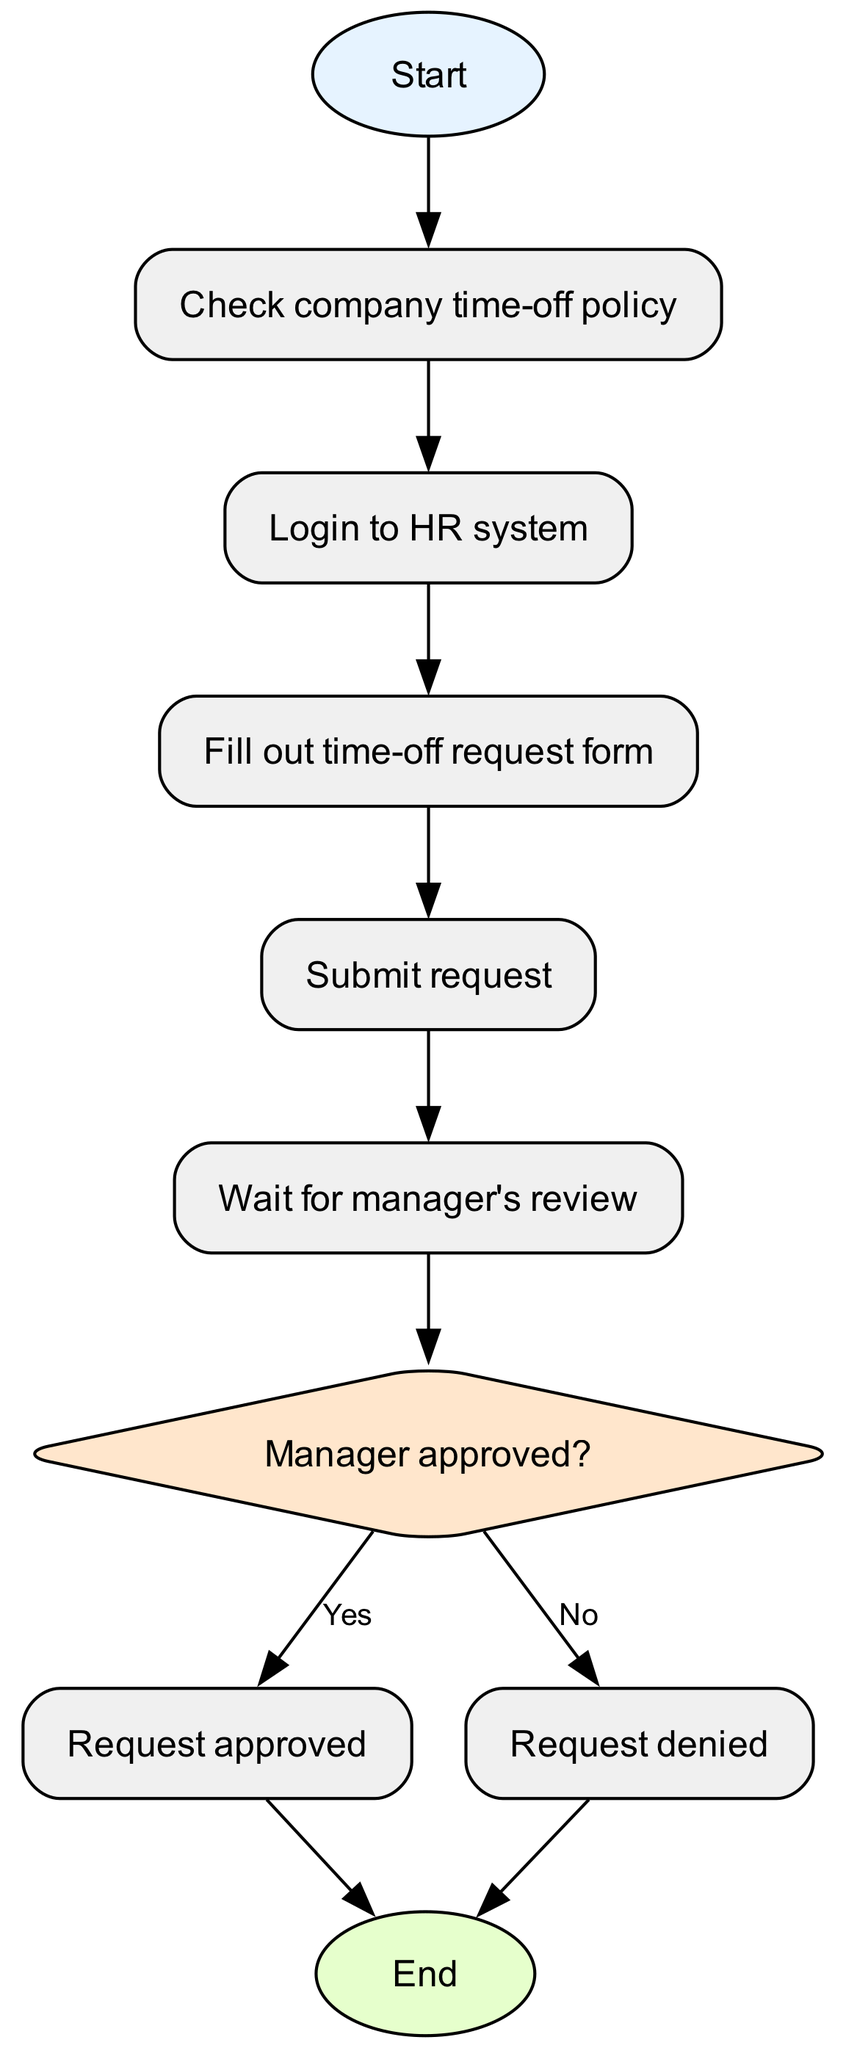What is the starting point of the process? The diagram begins with the "Start" node, indicating the entry point of the time-off request process.
Answer: Start What is the last step in the process? The process ends with the "End" node, signifying the completion of the time-off request flow.
Answer: End How many decision points are in the diagram? There is one decision node, asking if the manager approved the time-off request, which is a crucial point in the process.
Answer: 1 What comes after filling out the time-off request form? After the "Fill out time-off request form" step, the next node is "Submit request," indicating the sequence of actions.
Answer: Submit request What happens if the manager denies the request? If the manager denies the request, the process leads directly to the "End" node, signaling the conclusion of the request without approval.
Answer: End What are the two possible outcomes of the manager's decision? The manager's decision can either lead to "Request approved" or "Request denied," representing the potential results of the review process.
Answer: Request approved, Request denied What occurs after the request is submitted? The action that follows "Submit request" is "Wait for manager's review," which involves a pause for the decision-making process.
Answer: Wait for manager's review What step requires logging into a specific system? The step "Login to HR system" is clearly outlined as the action needed before filling out the request form.
Answer: Login to HR system What is the first action to take in the time-off request process? The initial action is to "Check company time-off policy," which sets the groundwork for making a request.
Answer: Check company time-off policy 